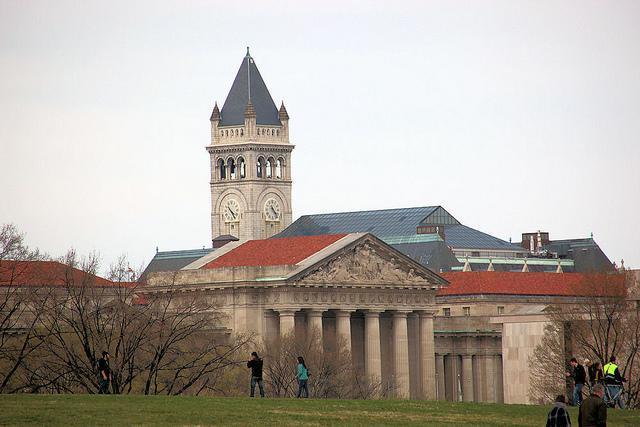How many cars contain coal?
Give a very brief answer. 0. 